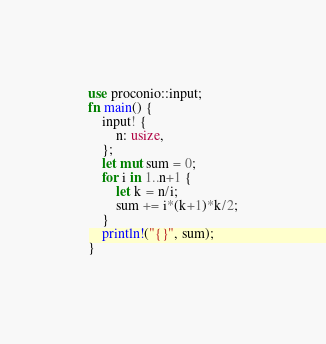Convert code to text. <code><loc_0><loc_0><loc_500><loc_500><_Rust_>use proconio::input;
fn main() {
    input! {
        n: usize,
    };
    let mut sum = 0;
    for i in 1..n+1 {
        let k = n/i;
        sum += i*(k+1)*k/2;
    }
    println!("{}", sum);
}</code> 